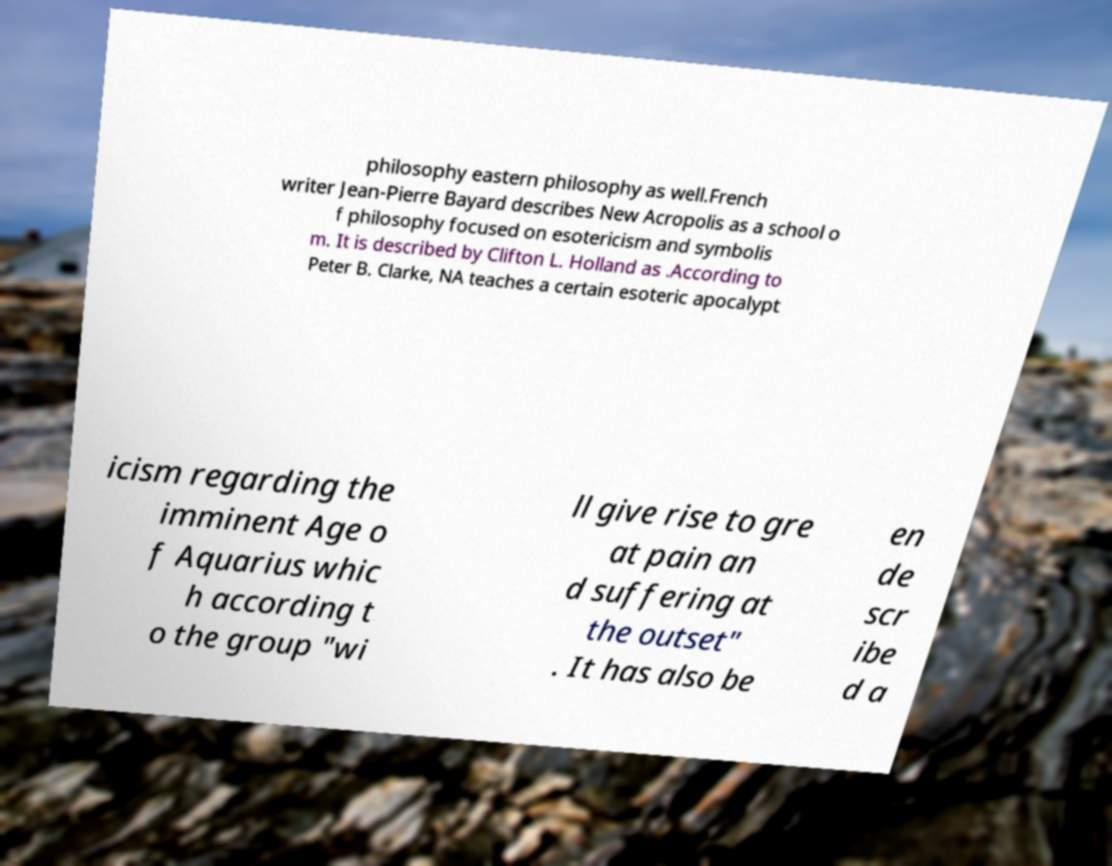Could you assist in decoding the text presented in this image and type it out clearly? philosophy eastern philosophy as well.French writer Jean-Pierre Bayard describes New Acropolis as a school o f philosophy focused on esotericism and symbolis m. It is described by Clifton L. Holland as .According to Peter B. Clarke, NA teaches a certain esoteric apocalypt icism regarding the imminent Age o f Aquarius whic h according t o the group "wi ll give rise to gre at pain an d suffering at the outset" . It has also be en de scr ibe d a 